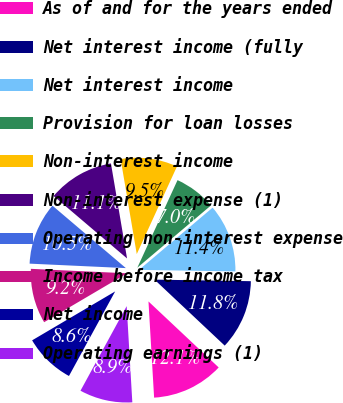<chart> <loc_0><loc_0><loc_500><loc_500><pie_chart><fcel>As of and for the years ended<fcel>Net interest income (fully<fcel>Net interest income<fcel>Provision for loan losses<fcel>Non-interest income<fcel>Non-interest expense (1)<fcel>Operating non-interest expense<fcel>Income before income tax<fcel>Net income<fcel>Operating earnings (1)<nl><fcel>12.06%<fcel>11.75%<fcel>11.43%<fcel>6.98%<fcel>9.52%<fcel>11.11%<fcel>10.48%<fcel>9.21%<fcel>8.57%<fcel>8.89%<nl></chart> 